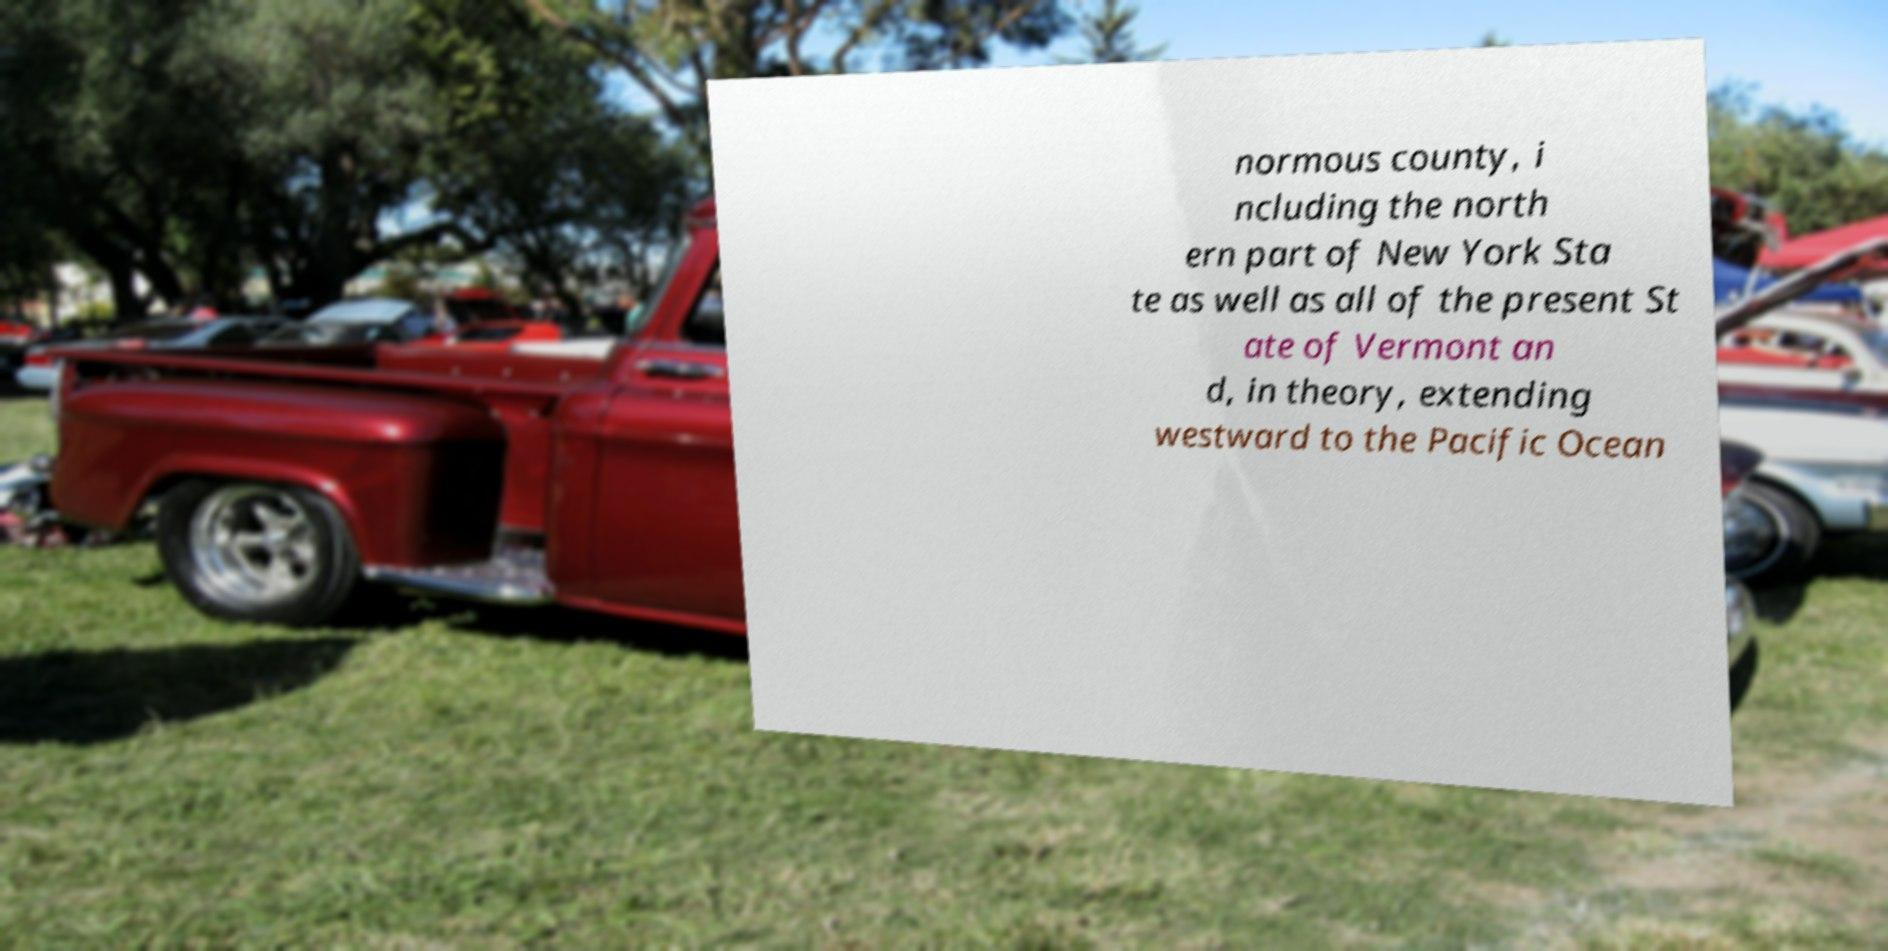For documentation purposes, I need the text within this image transcribed. Could you provide that? normous county, i ncluding the north ern part of New York Sta te as well as all of the present St ate of Vermont an d, in theory, extending westward to the Pacific Ocean 